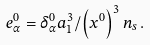<formula> <loc_0><loc_0><loc_500><loc_500>e _ { \alpha } ^ { 0 } = \delta _ { \alpha } ^ { 0 } a _ { 1 } ^ { 3 } / \left ( x ^ { 0 } \right ) ^ { 3 } n _ { s } \, .</formula> 